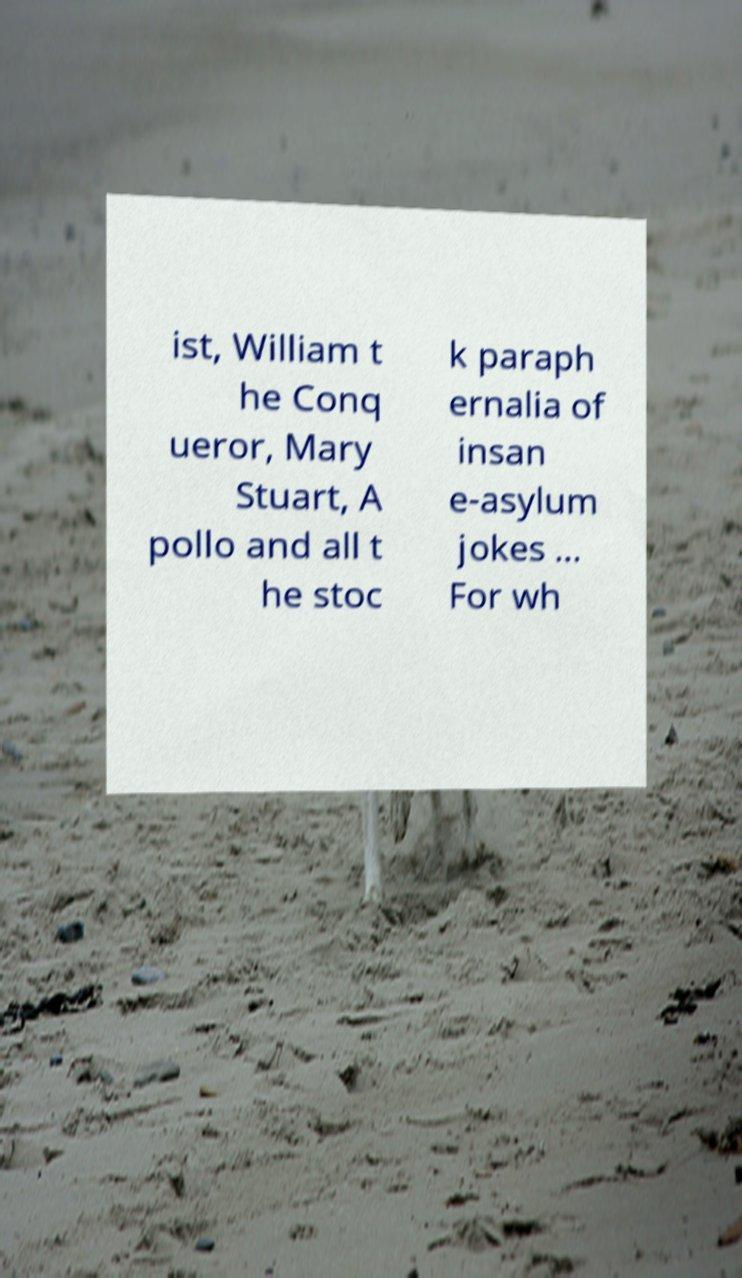What messages or text are displayed in this image? I need them in a readable, typed format. ist, William t he Conq ueror, Mary Stuart, A pollo and all t he stoc k paraph ernalia of insan e-asylum jokes ... For wh 